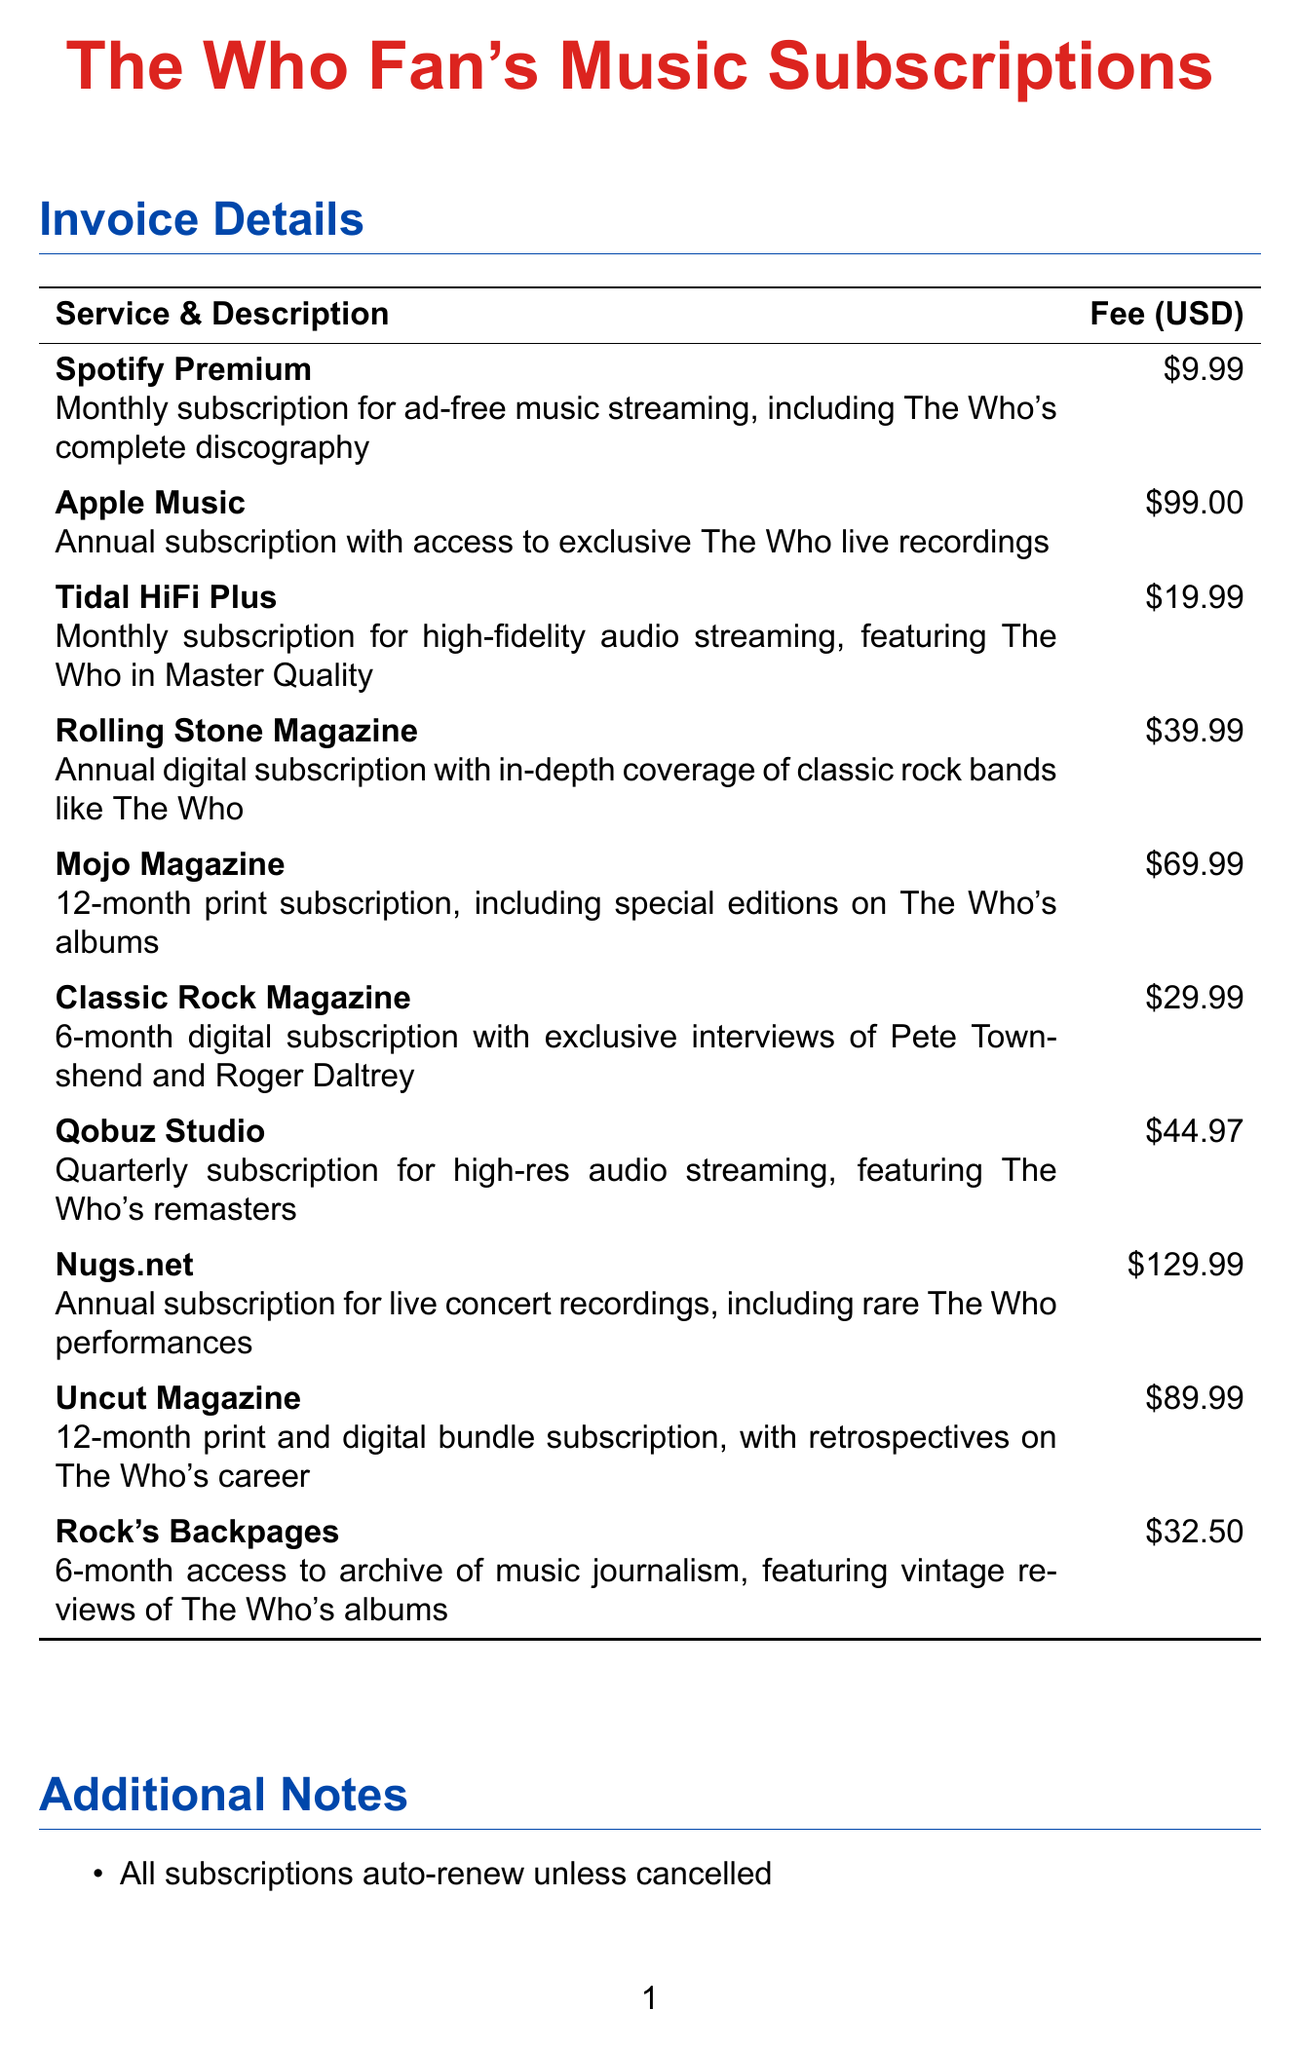What is the fee for Spotify Premium? The fee for Spotify Premium is listed in the document under the corresponding service.
Answer: $9.99 What type of subscription does Mojo Magazine offer? The document details the subscription type for Mojo Magazine, which is a print subscription.
Answer: Print How much is the annual subscription for Nugs.net? The document states the cost of the annual subscription for Nugs.net as listed.
Answer: $129.99 Which magazine provides in-depth coverage of classic rock bands? The document specifies a magazine that focuses on classic rock bands like The Who.
Answer: Rolling Stone Magazine What is the total fee for all monthly subscriptions? To find this, you sum up all the monthly subscription fees listed in the document.
Answer: $69.97 How long is the subscription for Classic Rock Magazine? The duration of the subscription for Classic Rock Magazine is mentioned in the document.
Answer: 6-month What do all subscriptions do by default unless cancelled? The document notes an action that occurs by default for all subscriptions, which is relevant for users.
Answer: Auto-renew Which service includes exclusive live recordings of The Who? The document specifies the service that offers exclusive live recordings of The Who.
Answer: Apple Music How many months is the subscription duration for Uncut Magazine? The document indicates the length of the subscription for Uncut Magazine.
Answer: 12-month 